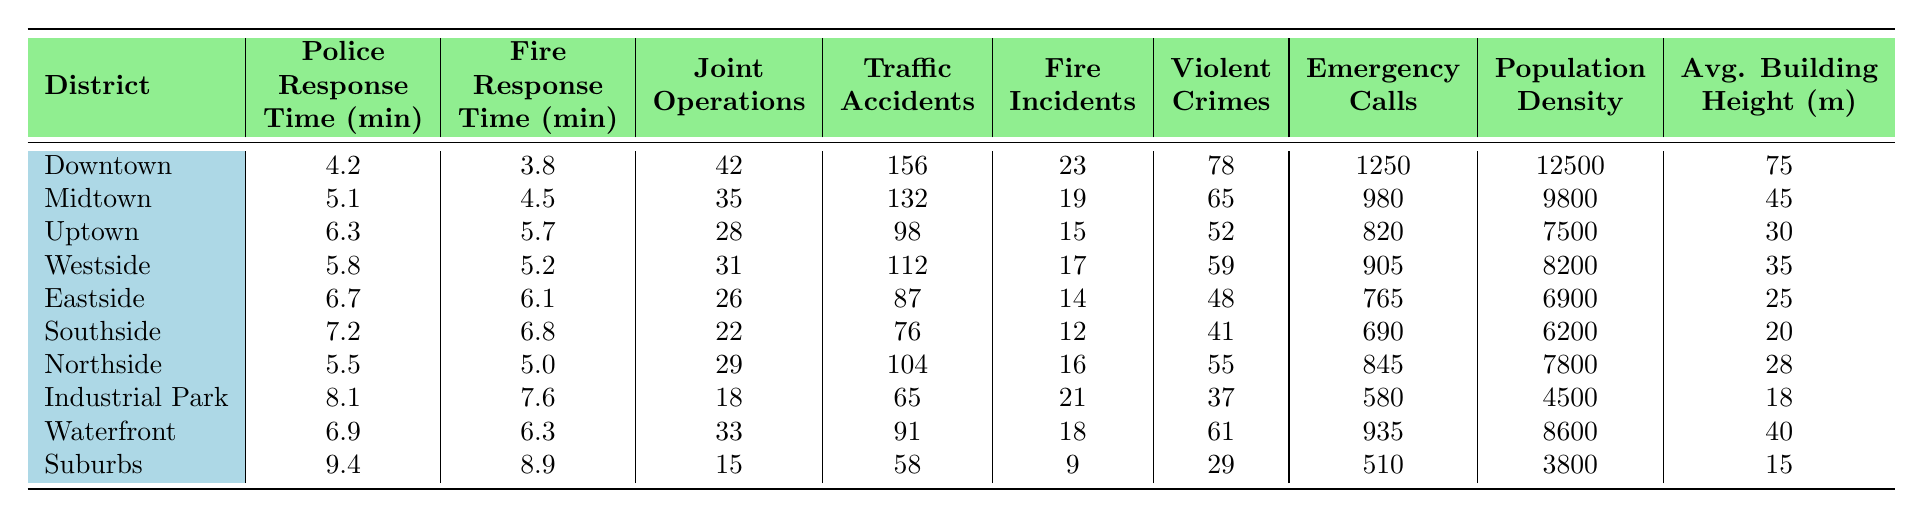What is the police response time in the Downtown district? The table shows that the police response time for Downtown is listed directly under the respective column. From the table, it is 4.2 minutes.
Answer: 4.2 minutes Which district has the highest fire response time? To find the highest fire response time, I look through the fire response time column. Comparing all values, the Suburbs district has the highest at 8.9 minutes.
Answer: Suburbs How many joint operations were conducted in the Eastside? The number of joint operations is provided in the corresponding column for each district. For Eastside, the value is 26.
Answer: 26 What is the average police response time across all districts? The police response times are: 4.2, 5.1, 6.3, 5.8, 6.7, 7.2, 5.5, 8.1, 6.9, 9.4. To find the average, I will sum these values (4.2 + 5.1 + 6.3 + 5.8 + 6.7 + 7.2 + 5.5 + 8.1 + 6.9 + 9.4 = 60.2) and divide by 10, giving an average of 6.02 minutes.
Answer: 6.02 minutes Is the traffic accident rate higher in Northside than in Southside? The table shows that Northside recorded 104 traffic accidents while Southside recorded 76. Since 104 is greater than 76, the statement is true.
Answer: Yes What is the total number of emergency calls made in the Downtown and Waterfront districts combined? The number of emergency calls for Downtown is 1250 and for Waterfront is 935. To find the total, sum these two values (1250 + 935 = 2185).
Answer: 2185 Which district has the lowest population density? Looking at the population density column, I can see that Suburbs has the lowest value listed at 3800.
Answer: Suburbs How does the average fire response time compare to the average police response time across all districts? Calculating the average fire response times: (3.8 + 4.5 + 5.7 + 5.2 + 6.1 + 6.8 + 5.0 + 7.6 + 6.3 + 8.9 = 60.9), the average is 60.9/10 = 6.09. The average police response time is 6.02. Comparing, 6.09 is greater than 6.02.
Answer: Fire response time is higher Given that the highest rate of violent crimes is in Downtown, is that also where the highest number of traffic accidents occurred? The highest number of violent crimes, 78, is in Downtown, but the number of traffic accidents there is 156. I check other districts to see if anyone had more accidents than Downtown; none exceed it. Therefore, Downtown does have the highest traffic accidents and violent crimes.
Answer: Yes Which district experiences more fire incidents, Northside or Eastside? Northside has 16 fire incidents while Eastside has 14. Thus, Northside is higher.
Answer: Northside 